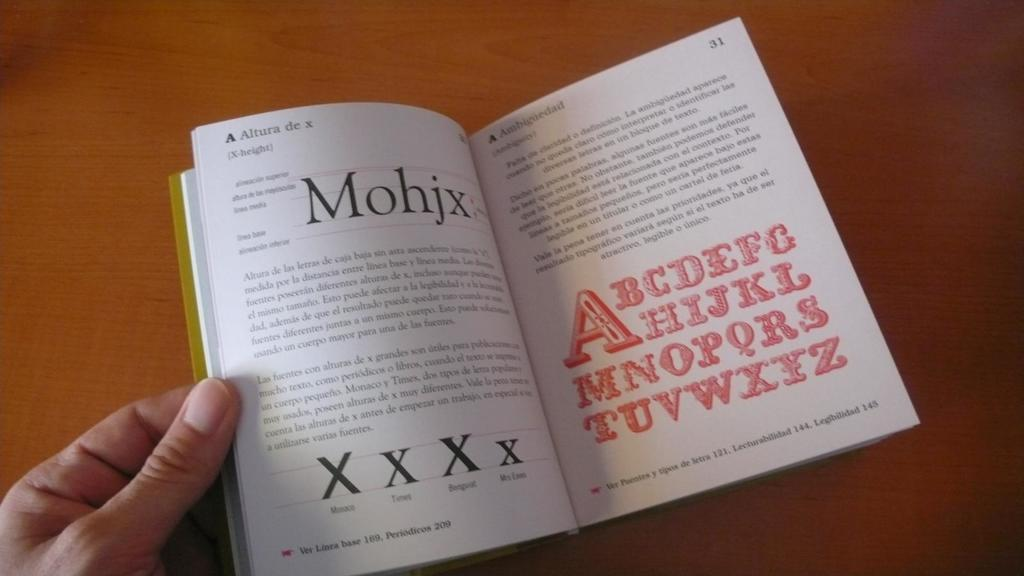<image>
Provide a brief description of the given image. A book opened to page 30 and 31, page 31 has the alphabet on it. 